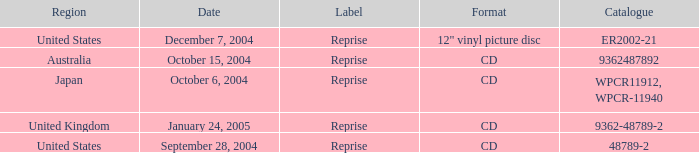Specify the register for australia 9362487892.0. 